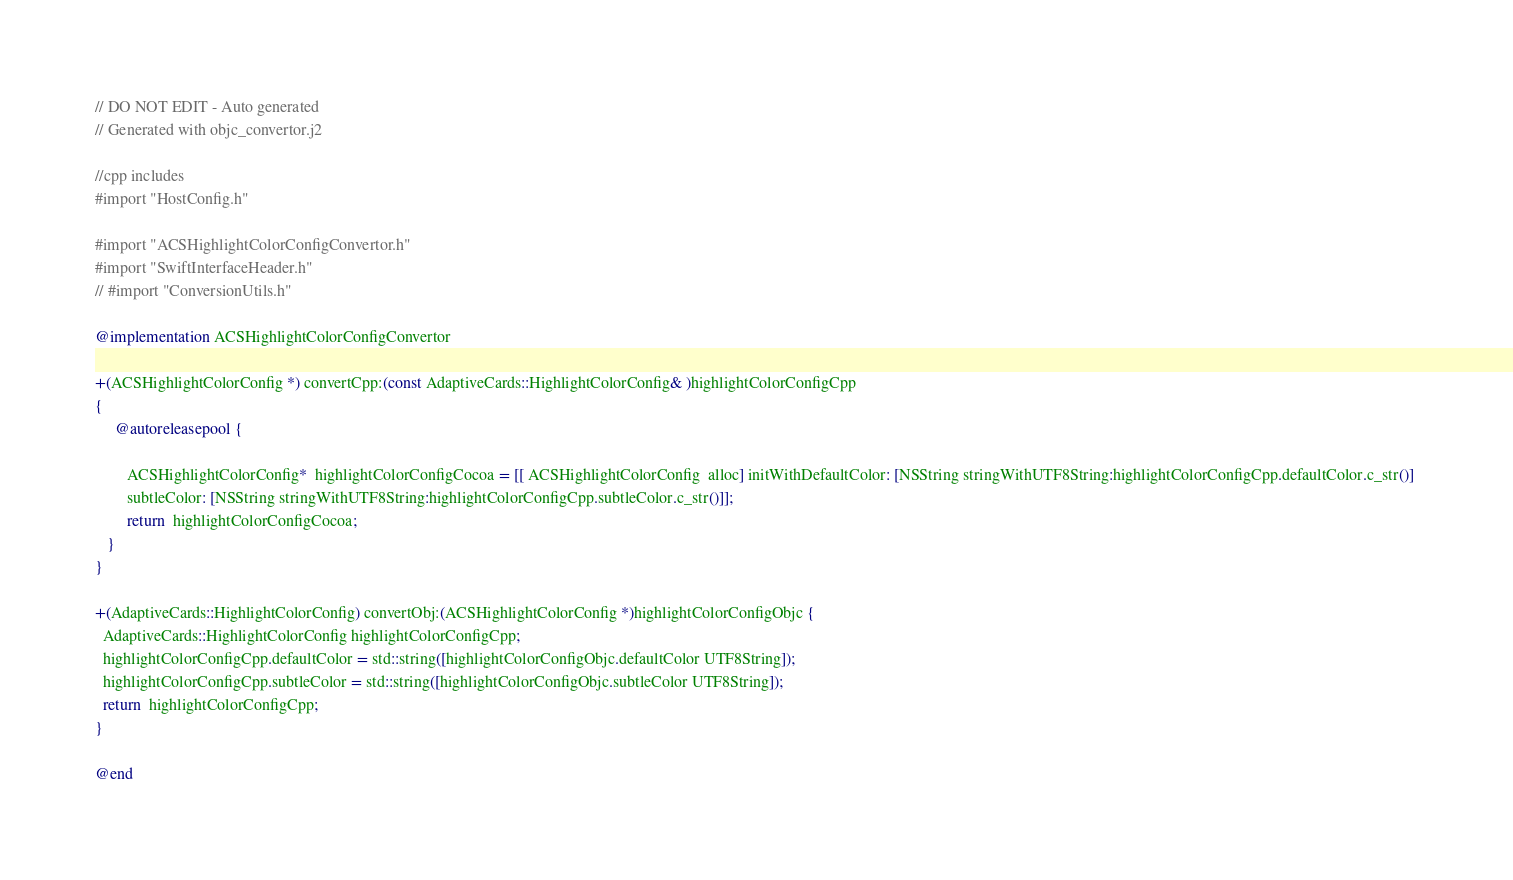Convert code to text. <code><loc_0><loc_0><loc_500><loc_500><_ObjectiveC_>// DO NOT EDIT - Auto generated
// Generated with objc_convertor.j2

//cpp includes 
#import "HostConfig.h"

#import "ACSHighlightColorConfigConvertor.h"
#import "SwiftInterfaceHeader.h"
// #import "ConversionUtils.h"

@implementation ACSHighlightColorConfigConvertor 

+(ACSHighlightColorConfig *) convertCpp:(const AdaptiveCards::HighlightColorConfig& )highlightColorConfigCpp
{ 
     @autoreleasepool { 
 
        ACSHighlightColorConfig*  highlightColorConfigCocoa = [[ ACSHighlightColorConfig  alloc] initWithDefaultColor: [NSString stringWithUTF8String:highlightColorConfigCpp.defaultColor.c_str()] 
        subtleColor: [NSString stringWithUTF8String:highlightColorConfigCpp.subtleColor.c_str()]];
        return  highlightColorConfigCocoa;
   }
}

+(AdaptiveCards::HighlightColorConfig) convertObj:(ACSHighlightColorConfig *)highlightColorConfigObjc {
  AdaptiveCards::HighlightColorConfig highlightColorConfigCpp;
  highlightColorConfigCpp.defaultColor = std::string([highlightColorConfigObjc.defaultColor UTF8String]);
  highlightColorConfigCpp.subtleColor = std::string([highlightColorConfigObjc.subtleColor UTF8String]);
  return  highlightColorConfigCpp;
}

@end 
</code> 